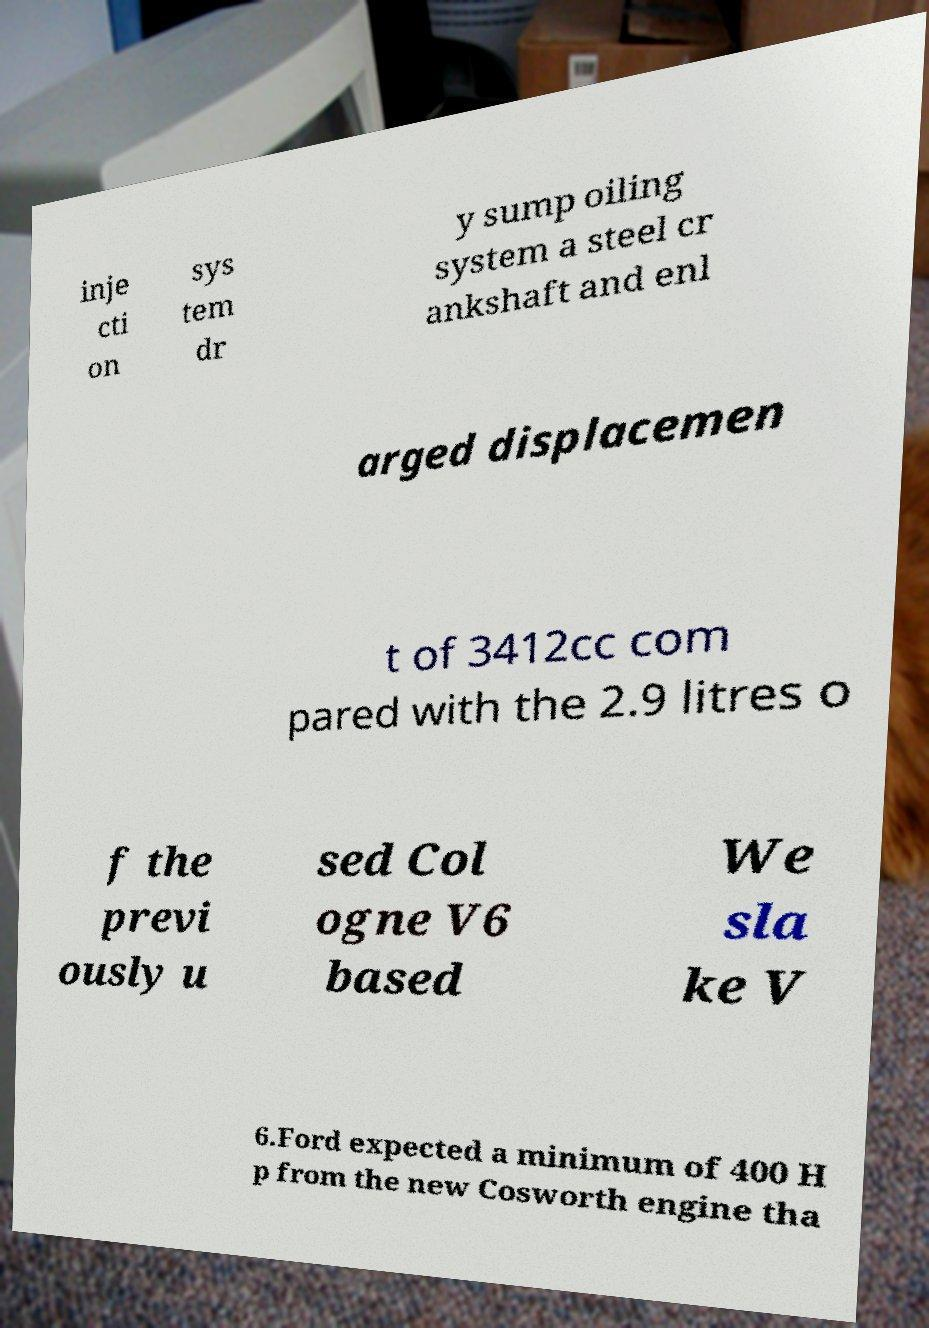What messages or text are displayed in this image? I need them in a readable, typed format. inje cti on sys tem dr y sump oiling system a steel cr ankshaft and enl arged displacemen t of 3412cc com pared with the 2.9 litres o f the previ ously u sed Col ogne V6 based We sla ke V 6.Ford expected a minimum of 400 H p from the new Cosworth engine tha 